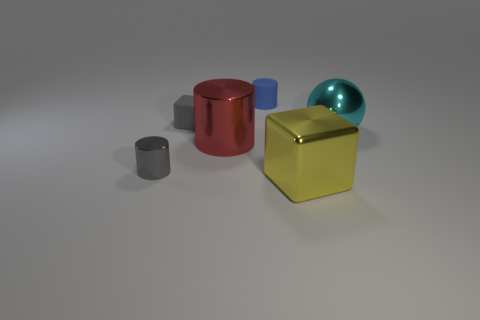Add 2 cylinders. How many objects exist? 8 Subtract all cubes. How many objects are left? 4 Subtract 0 green spheres. How many objects are left? 6 Subtract all gray blocks. Subtract all gray metal things. How many objects are left? 4 Add 1 large shiny cubes. How many large shiny cubes are left? 2 Add 5 gray rubber things. How many gray rubber things exist? 6 